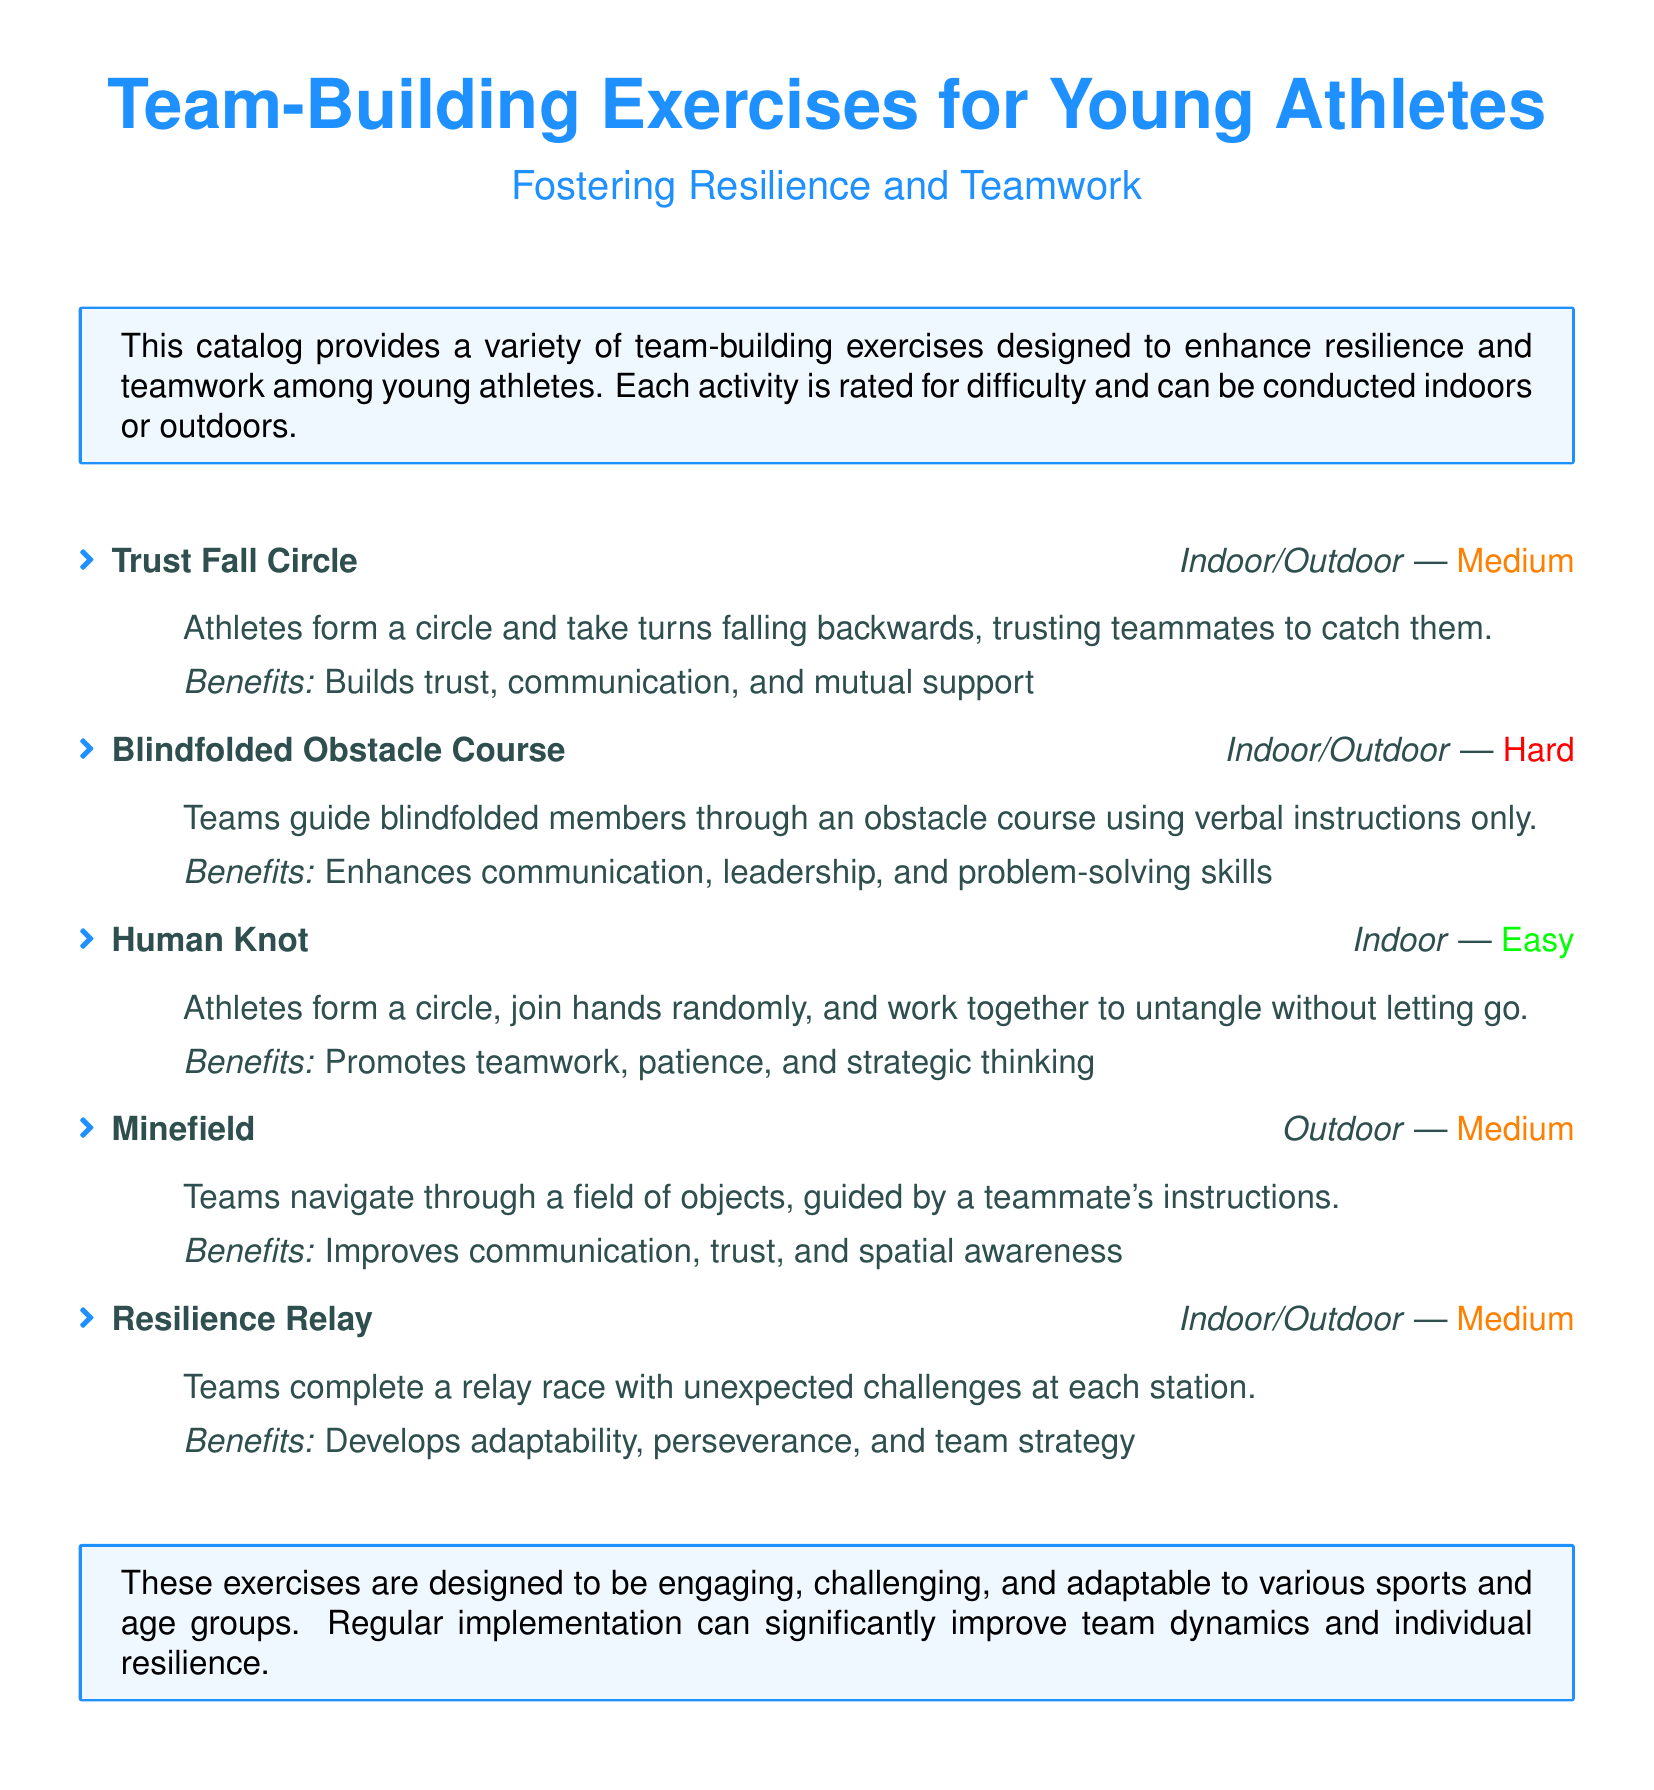What is the title of the catalog? The title is provided at the beginning of the document.
Answer: Team-Building Exercises for Young Athletes How many team-building exercises are listed in the document? The document lists a total of five exercises.
Answer: 5 Which exercise is rated as 'Hard'? The difficulty ratings for all exercises are indicated next to their titles.
Answer: Blindfolded Obstacle Course What is the primary benefit of the 'Trust Fall Circle' exercise? The document outlines specific benefits for each exercise.
Answer: Builds trust, communication, and mutual support What type of activities does the catalog include? The introduction mentions the activities are designed for specific settings.
Answer: Indoor and outdoor activities Which activity involves navigating a field of objects? The description under the relevant exercise provides details about this activity.
Answer: Minefield What is the difficulty rating for the 'Human Knot' exercise? The assigned difficulty rating is mentioned in the details of the exercise.
Answer: Easy How does the 'Resilience Relay' exercise enhance team strategy? The description specifies how the exercise develops various skills.
Answer: Develops adaptability, perseverance, and team strategy 